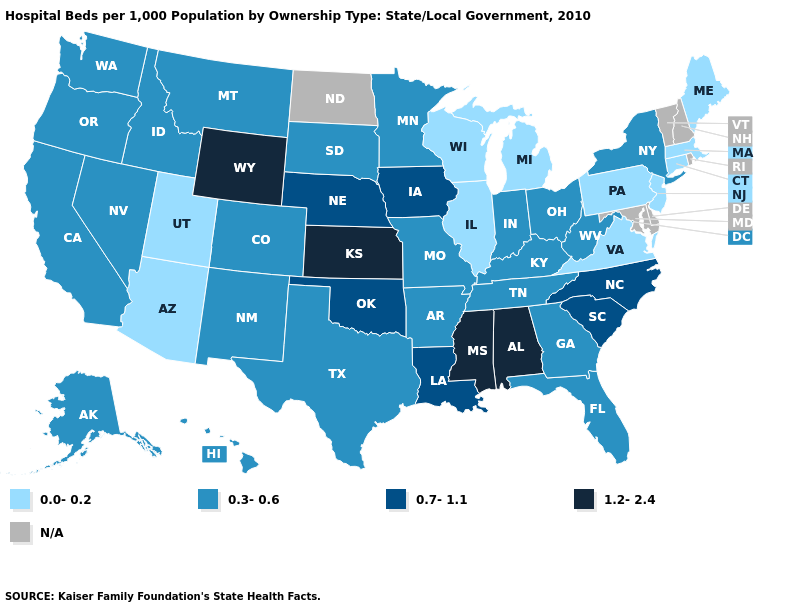Which states have the lowest value in the Northeast?
Keep it brief. Connecticut, Maine, Massachusetts, New Jersey, Pennsylvania. What is the value of Illinois?
Concise answer only. 0.0-0.2. Name the states that have a value in the range N/A?
Answer briefly. Delaware, Maryland, New Hampshire, North Dakota, Rhode Island, Vermont. Which states hav the highest value in the MidWest?
Concise answer only. Kansas. Name the states that have a value in the range 1.2-2.4?
Write a very short answer. Alabama, Kansas, Mississippi, Wyoming. What is the value of Texas?
Be succinct. 0.3-0.6. How many symbols are there in the legend?
Short answer required. 5. Which states have the lowest value in the West?
Give a very brief answer. Arizona, Utah. What is the lowest value in the Northeast?
Keep it brief. 0.0-0.2. What is the value of Hawaii?
Give a very brief answer. 0.3-0.6. What is the value of Connecticut?
Give a very brief answer. 0.0-0.2. What is the highest value in states that border New Jersey?
Give a very brief answer. 0.3-0.6. 